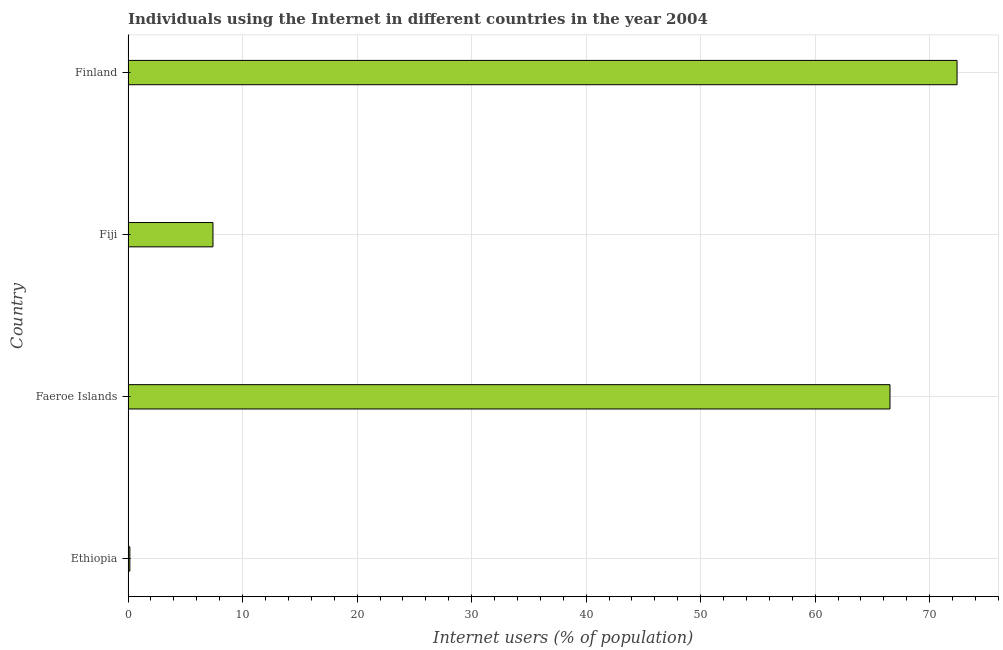What is the title of the graph?
Your answer should be very brief. Individuals using the Internet in different countries in the year 2004. What is the label or title of the X-axis?
Provide a succinct answer. Internet users (% of population). What is the number of internet users in Fiji?
Make the answer very short. 7.41. Across all countries, what is the maximum number of internet users?
Keep it short and to the point. 72.39. Across all countries, what is the minimum number of internet users?
Your answer should be very brief. 0.16. In which country was the number of internet users minimum?
Offer a terse response. Ethiopia. What is the sum of the number of internet users?
Make the answer very short. 146.49. What is the difference between the number of internet users in Ethiopia and Finland?
Make the answer very short. -72.23. What is the average number of internet users per country?
Provide a short and direct response. 36.62. What is the median number of internet users?
Make the answer very short. 36.97. What is the ratio of the number of internet users in Faeroe Islands to that in Finland?
Offer a very short reply. 0.92. Is the number of internet users in Faeroe Islands less than that in Finland?
Offer a terse response. Yes. What is the difference between the highest and the second highest number of internet users?
Make the answer very short. 5.86. Is the sum of the number of internet users in Fiji and Finland greater than the maximum number of internet users across all countries?
Provide a short and direct response. Yes. What is the difference between the highest and the lowest number of internet users?
Provide a succinct answer. 72.23. What is the difference between two consecutive major ticks on the X-axis?
Give a very brief answer. 10. What is the Internet users (% of population) of Ethiopia?
Offer a terse response. 0.16. What is the Internet users (% of population) in Faeroe Islands?
Offer a terse response. 66.53. What is the Internet users (% of population) in Fiji?
Offer a terse response. 7.41. What is the Internet users (% of population) of Finland?
Your response must be concise. 72.39. What is the difference between the Internet users (% of population) in Ethiopia and Faeroe Islands?
Provide a short and direct response. -66.38. What is the difference between the Internet users (% of population) in Ethiopia and Fiji?
Offer a terse response. -7.26. What is the difference between the Internet users (% of population) in Ethiopia and Finland?
Give a very brief answer. -72.23. What is the difference between the Internet users (% of population) in Faeroe Islands and Fiji?
Your answer should be compact. 59.12. What is the difference between the Internet users (% of population) in Faeroe Islands and Finland?
Your answer should be very brief. -5.86. What is the difference between the Internet users (% of population) in Fiji and Finland?
Ensure brevity in your answer.  -64.98. What is the ratio of the Internet users (% of population) in Ethiopia to that in Faeroe Islands?
Ensure brevity in your answer.  0. What is the ratio of the Internet users (% of population) in Ethiopia to that in Fiji?
Your answer should be very brief. 0.02. What is the ratio of the Internet users (% of population) in Ethiopia to that in Finland?
Your answer should be compact. 0. What is the ratio of the Internet users (% of population) in Faeroe Islands to that in Fiji?
Provide a succinct answer. 8.97. What is the ratio of the Internet users (% of population) in Faeroe Islands to that in Finland?
Offer a terse response. 0.92. What is the ratio of the Internet users (% of population) in Fiji to that in Finland?
Ensure brevity in your answer.  0.1. 